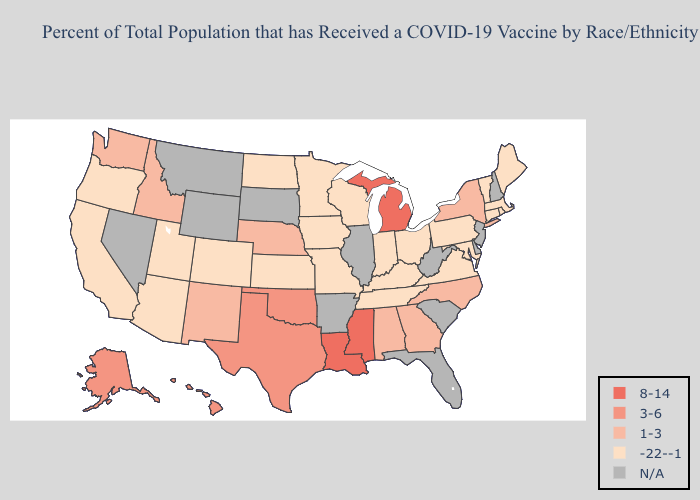What is the lowest value in states that border New Jersey?
Write a very short answer. -22--1. What is the highest value in states that border Florida?
Be succinct. 1-3. What is the lowest value in the South?
Write a very short answer. -22--1. Does Texas have the highest value in the South?
Concise answer only. No. Does Hawaii have the lowest value in the West?
Answer briefly. No. Among the states that border Texas , does Louisiana have the highest value?
Be succinct. Yes. What is the highest value in the USA?
Short answer required. 8-14. What is the value of Montana?
Quick response, please. N/A. Name the states that have a value in the range 8-14?
Give a very brief answer. Louisiana, Michigan, Mississippi. Name the states that have a value in the range 1-3?
Quick response, please. Alabama, Georgia, Idaho, Nebraska, New Mexico, New York, North Carolina, Washington. What is the lowest value in the West?
Short answer required. -22--1. What is the value of New York?
Quick response, please. 1-3. Among the states that border Wisconsin , does Michigan have the highest value?
Short answer required. Yes. Which states have the highest value in the USA?
Concise answer only. Louisiana, Michigan, Mississippi. What is the value of Idaho?
Short answer required. 1-3. 